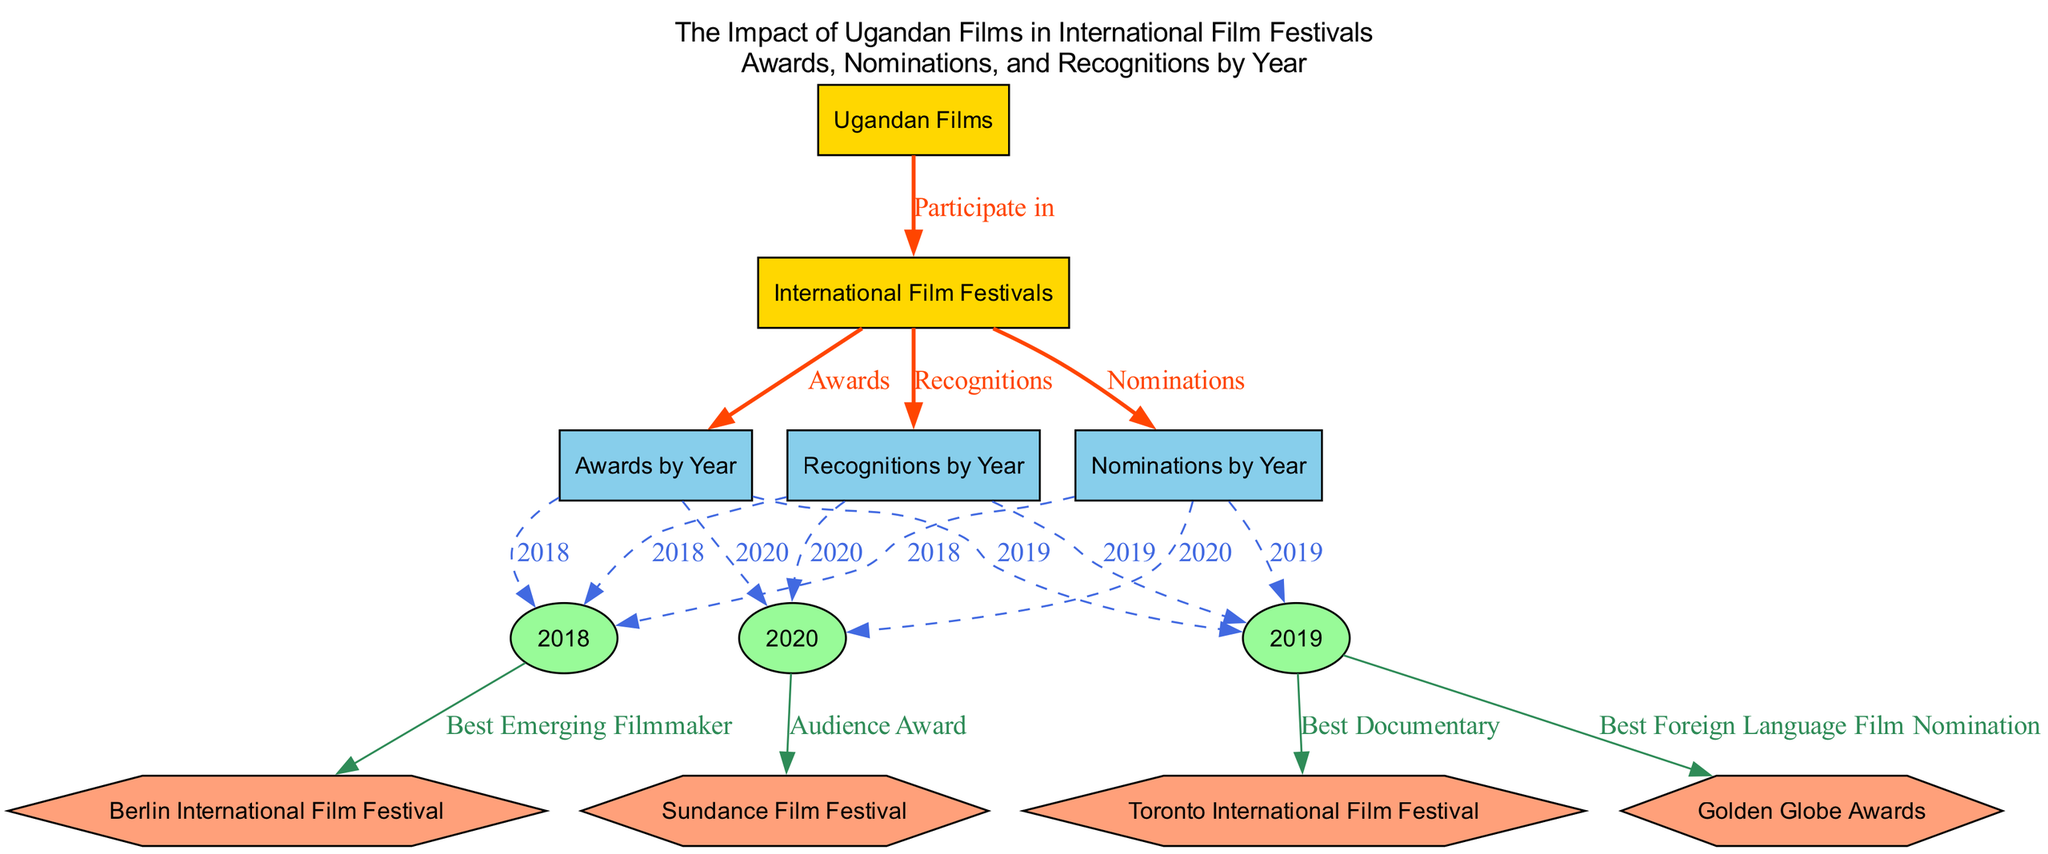What are the three main categories shown in the diagram? The diagram consists of three main categories: Awards by Year, Nominations by Year, and Recognitions by Year. These are essential components that categorize the achievements of Ugandan films in international film festivals.
Answer: Awards by Year, Nominations by Year, Recognitions by Year How many years are represented in the diagram? The diagram shows three specific years: 2018, 2019, and 2020. By counting the nodes that represent these years, we find that there are three distinct years categorized in the visual representation.
Answer: 3 Which international film festival is associated with the award for Best Emerging Filmmaker? The association can be traced from the node representing the year 2018, which has an edge leading to the Berlin International Film Festival labeled with "Best Emerging Filmmaker." Therefore, the answer is Berlin International Film Festival.
Answer: Berlin International Film Festival How many different awards are listed for the year 2019? There are two awards listed under the year 2019: one at the Toronto International Film Festival for "Best Documentary" and another at the Golden Globe Awards for "Best Foreign Language Film Nomination." By enumerating the edges from the 2019 node, we can confirm this count.
Answer: 2 Which two years show nominations in the diagram? The years 2018 and 2019 are the only years connected to the Nominations by Year node, which indicates that they both had nominations at international film festivals. Thus, examining the connections leads us to these two years.
Answer: 2018, 2019 Which award was received at the Sundance Film Festival in 2020? The diagram has an edge from the 2020 node leading to the Sundance Film Festival with the label "Audience Award." This indicates the specific award received, and by checking the details linked to the 2020 node, we can confirm this.
Answer: Audience Award What was the recognition received by Ugandan films in 2019? The edge from the 2019 node to Recognitions by Year shows there is a connection, but the specific recognition is not directly mentioned in the provided diagram details. One must look closely at the other factors or elements connected to 2019 to see if any recognition flows therein. However, given 2019 only shows nominations and awards, the lack of a specific mention means we cannot identify a unique recognition.
Answer: Not specified What is the relationship between Ugandan Films and International Film Festivals described in the diagram? The diagram indicates that Ugandan Films participate in International Film Festivals, as seen from the directed edge connecting the two with the label "Participate in." This establishes a clear relationship indicating involvement and representation in global cinema circles.
Answer: Participate in Which category does the audience award for 2020 belong to? The Audience Award from the Sundance Film Festival for 2020 falls under the category of Awards by Year, signified by the direct connection on the graph. This categorization illustrates the achievement of Ugandan films in that year at a prominent festival.
Answer: Awards by Year 